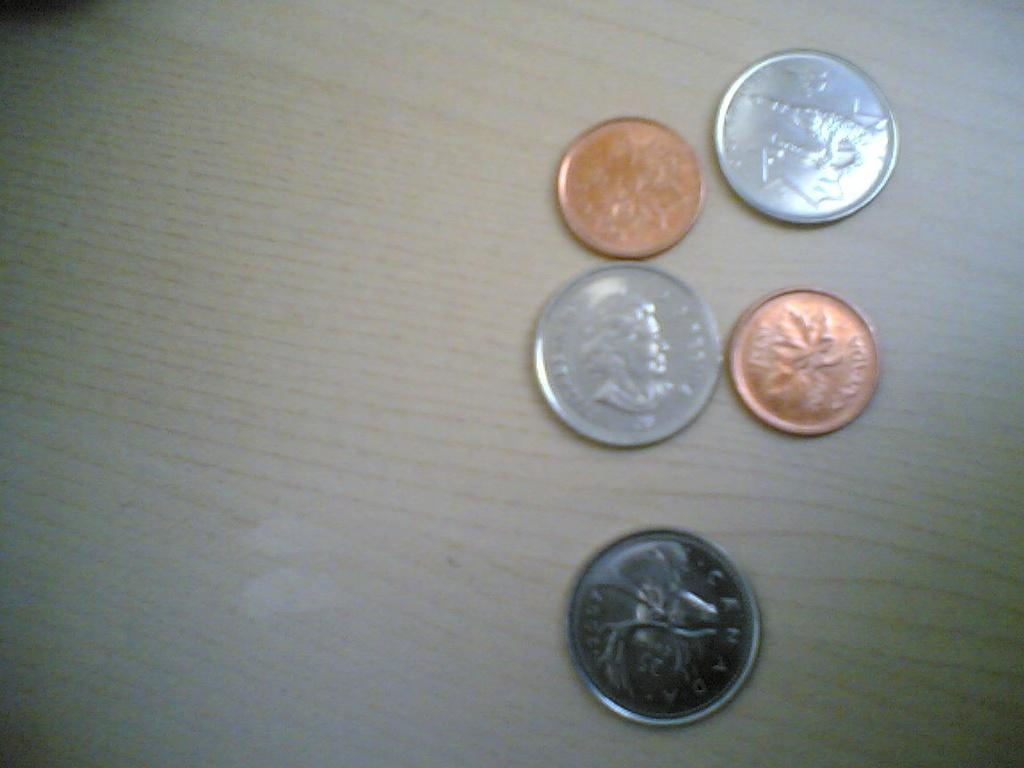<image>
Create a compact narrative representing the image presented. 1997 is stamped on the face of the bottom coin. 